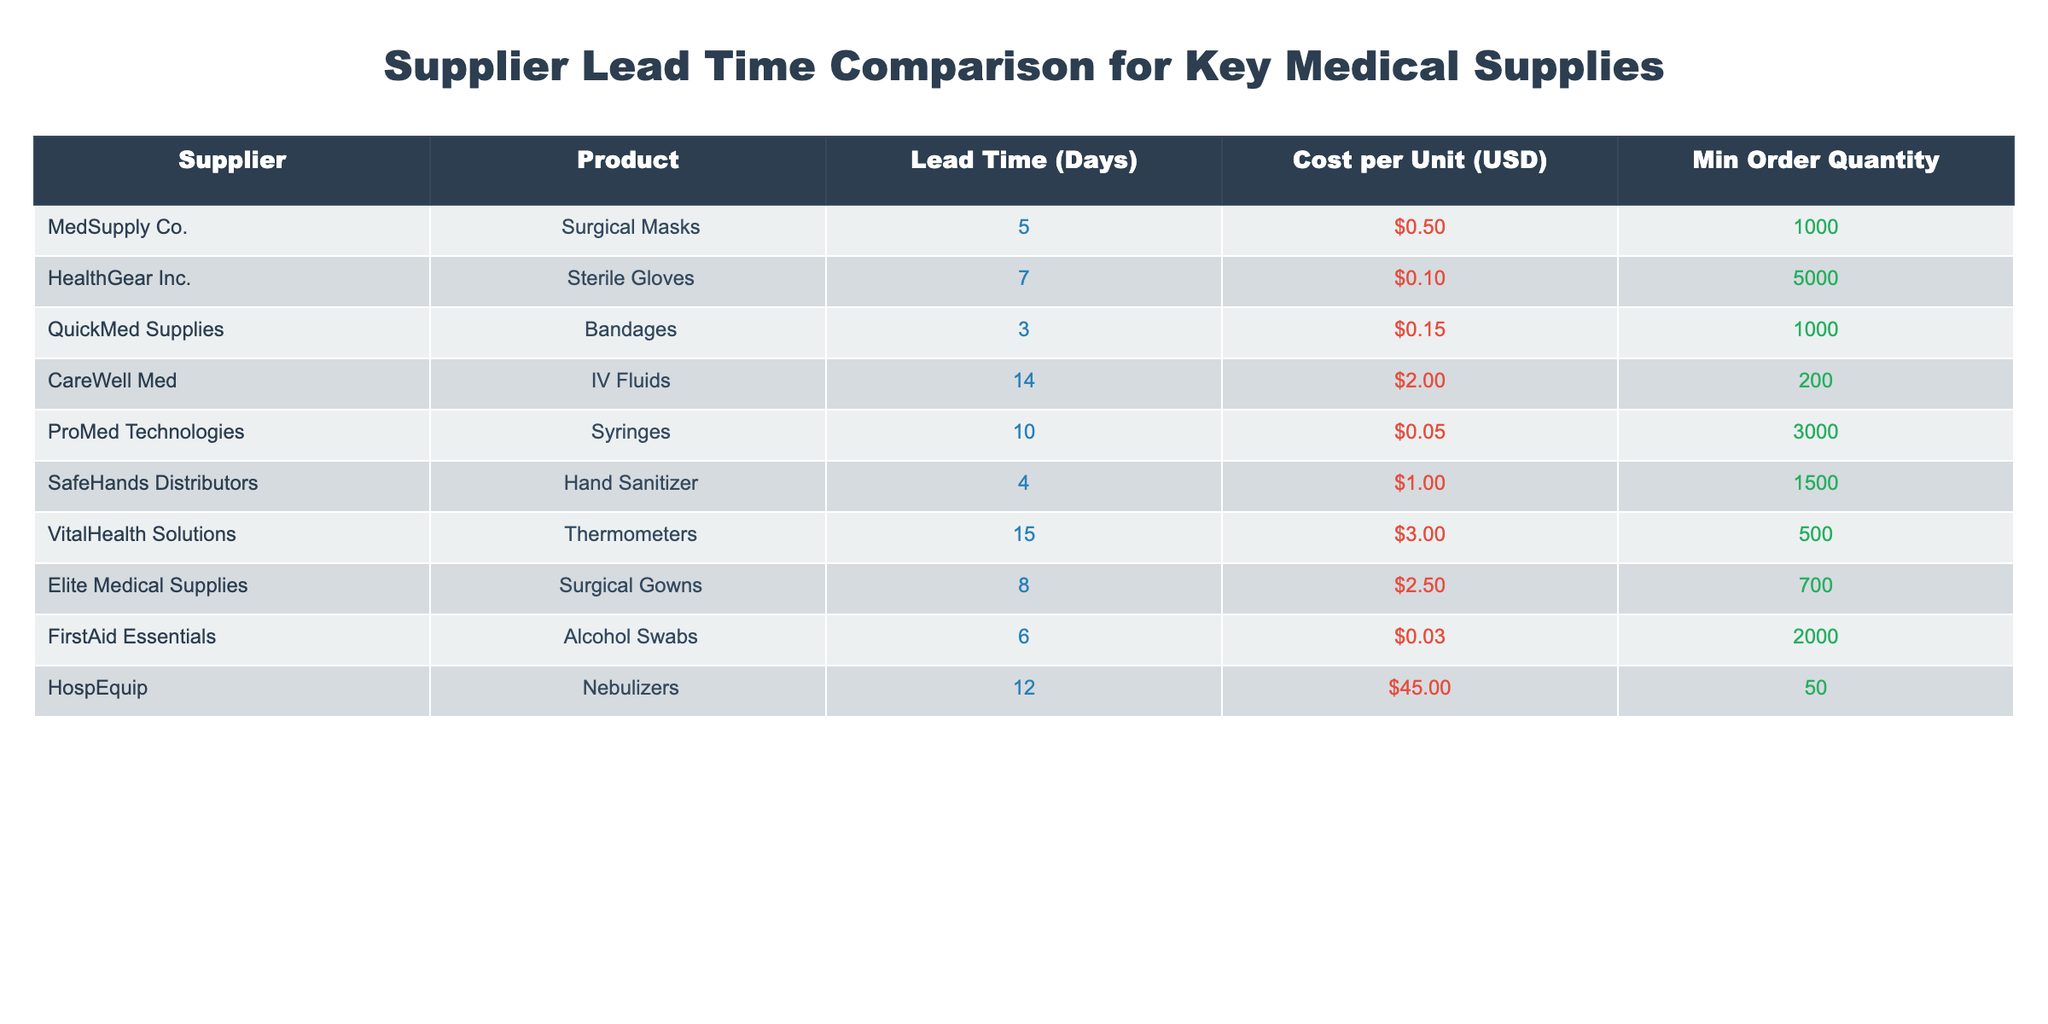What is the lead time for surgical masks from MedSupply Co.? The table shows that MedSupply Co. has a lead time of 5 days for surgical masks. This value can be found directly under the "Lead Time (Days)" column aligned with MedSupply Co. in the "Supplier" row.
Answer: 5 days Which supplier has the shortest lead time for medical supplies? By examining the "Lead Time (Days)" column, we see that QuickMed Supplies has the shortest lead time of 3 days for bandages. This is the lowest value in the column.
Answer: QuickMed Supplies How many days does it take to receive IV fluids from CareWell Med? The table indicates that CareWell Med requires a lead time of 14 days for IV fluids. This value corresponds to CareWell Med's entry in the table within the "Lead Time (Days)" column.
Answer: 14 days What is the total minimum order quantity for bandages and hand sanitizer? The minimum order quantity for bandages from QuickMed Supplies is 1000, and for hand sanitizer from SafeHands Distributors, it is 1500. Adding these values together gives 1000 + 1500 = 2500.
Answer: 2500 Is the cost per unit for sterile gloves less than the cost per unit for surgical gowns? The cost for sterile gloves is 0.10 and the cost for surgical gowns is 2.50. Since 0.10 is less than 2.50, the answer is yes. This comparison is directly made by checking the values in the respective "Cost per Unit (USD)" column.
Answer: Yes If you order the minimum quantity for thermometers, what is the total cost? The minimum order quantity for thermometers from VitalHealth Solutions is 500, and the cost per unit is 3.00. To calculate the total cost, multiply the minimum order quantity by the cost per unit: 500 * 3.00 = 1500.
Answer: 1500 Which supplier provides hand sanitizer with the shortest lead time? SafeHands Distributors is the supplier for hand sanitizer, which is shown to have a lead time of 4 days. Since we are only considering one supplier for hand sanitizer, this is the answer.
Answer: SafeHands Distributors What is the difference in lead time between the fastest and the slowest suppliers? The fastest lead time is 3 days from QuickMed Supplies (bandages), and the slowest is 15 days from VitalHealth Solutions (thermometers). The difference is calculated as 15 - 3 = 12 days.
Answer: 12 days Does proMed Technologies have a lead time of over ten days? The lead time from ProMed Technologies for syringes is 10 days. Since the question is asking if it is over ten days, and 10 is not greater than 10, the answer is no.
Answer: No 